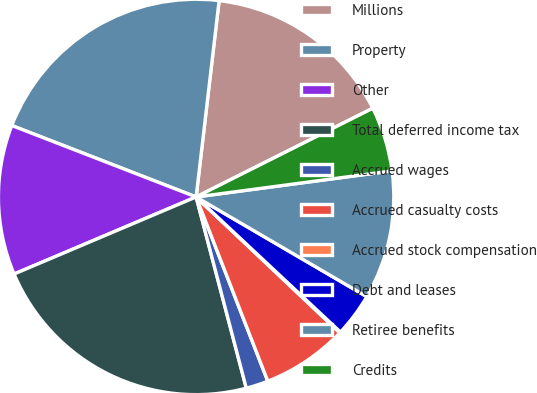<chart> <loc_0><loc_0><loc_500><loc_500><pie_chart><fcel>Millions<fcel>Property<fcel>Other<fcel>Total deferred income tax<fcel>Accrued wages<fcel>Accrued casualty costs<fcel>Accrued stock compensation<fcel>Debt and leases<fcel>Retiree benefits<fcel>Credits<nl><fcel>15.74%<fcel>20.97%<fcel>12.26%<fcel>22.71%<fcel>1.82%<fcel>7.04%<fcel>0.08%<fcel>3.56%<fcel>10.52%<fcel>5.3%<nl></chart> 